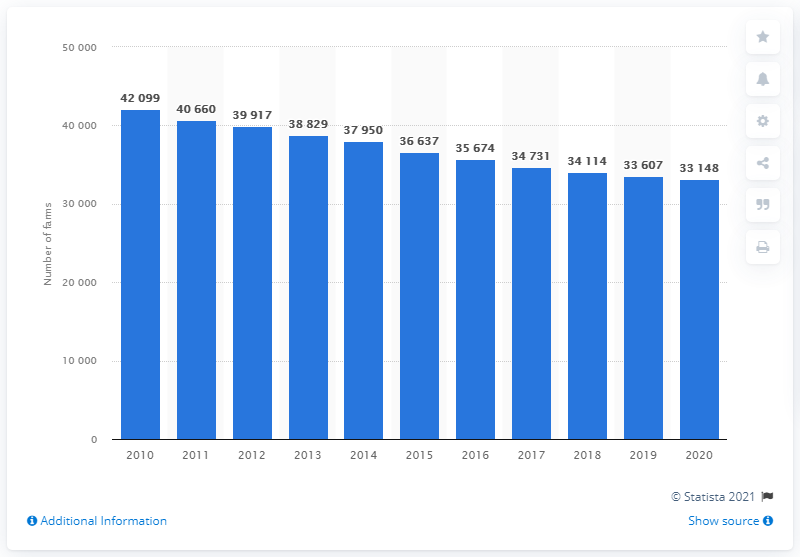List a handful of essential elements in this visual. There were 33,148 farms in Denmark in 2020. 